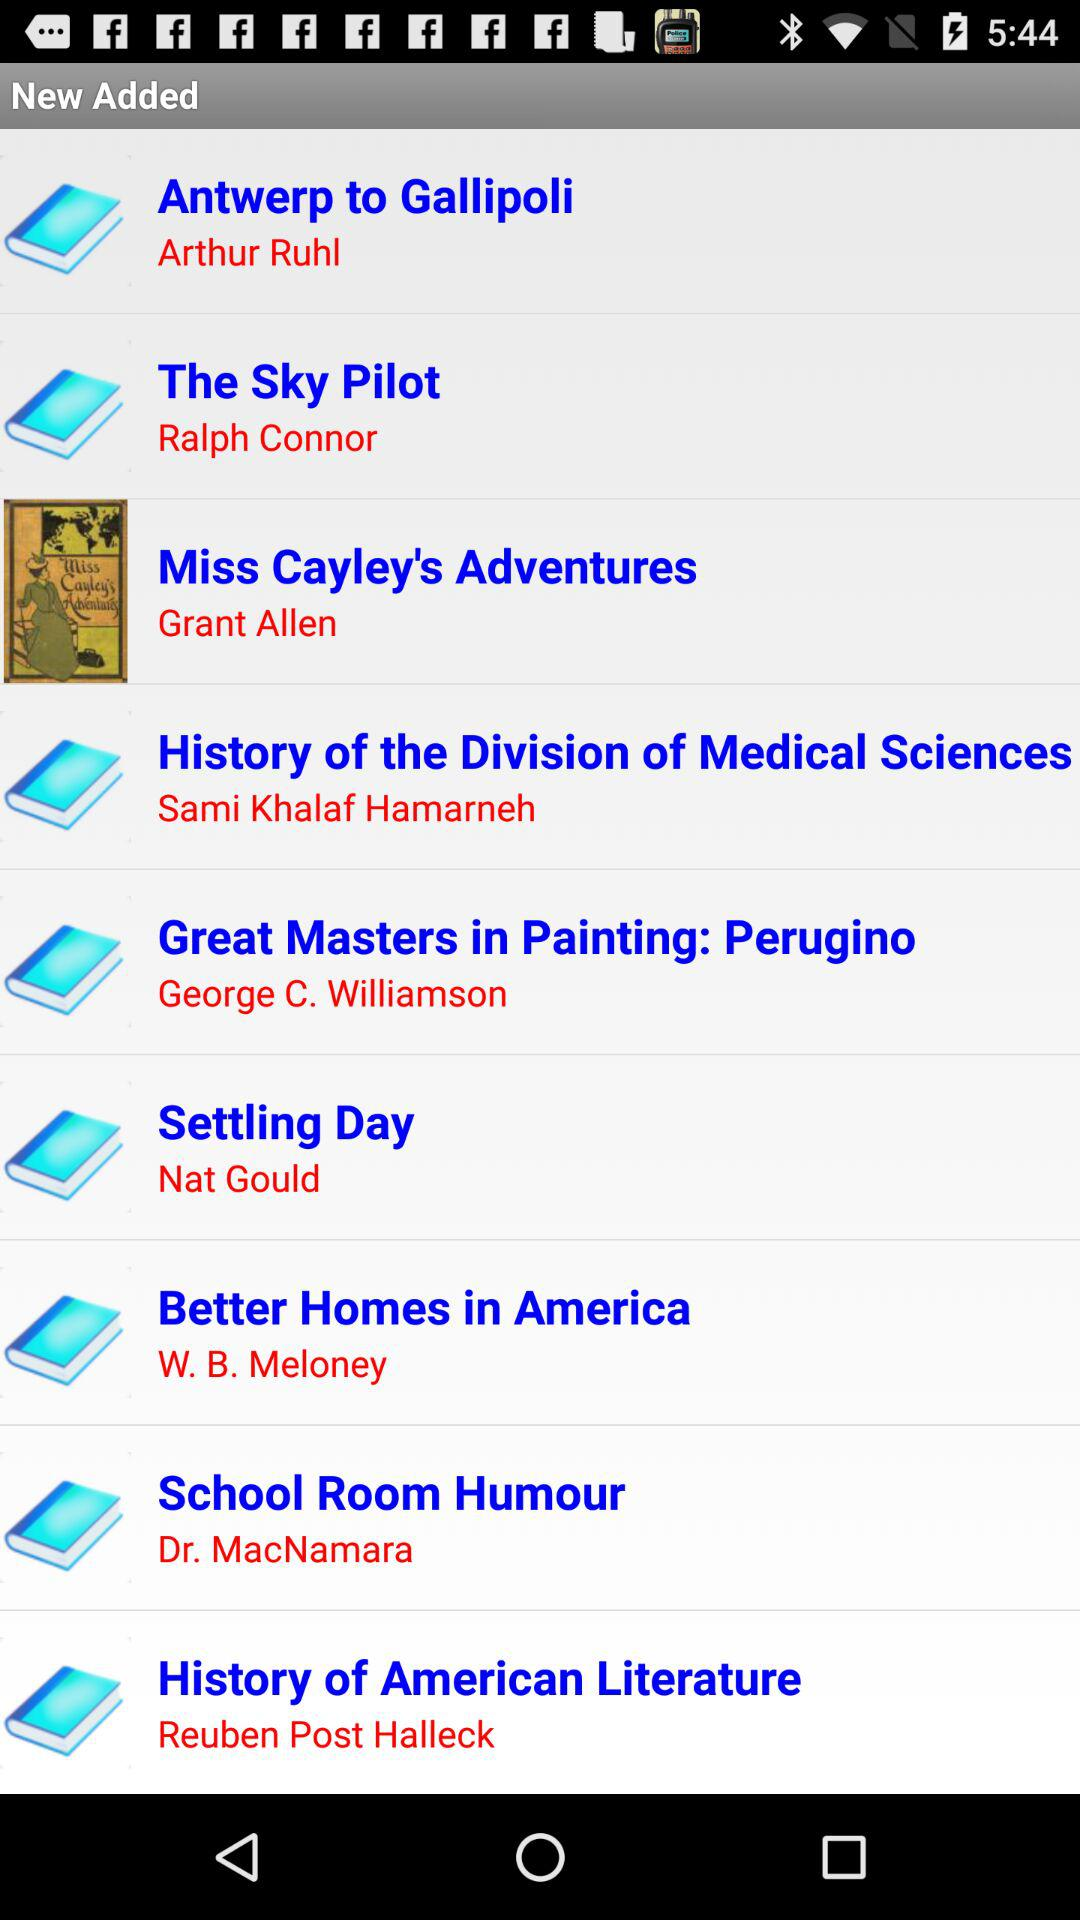Who is the author of the book Settling Day? The author is "Nat Gould". 